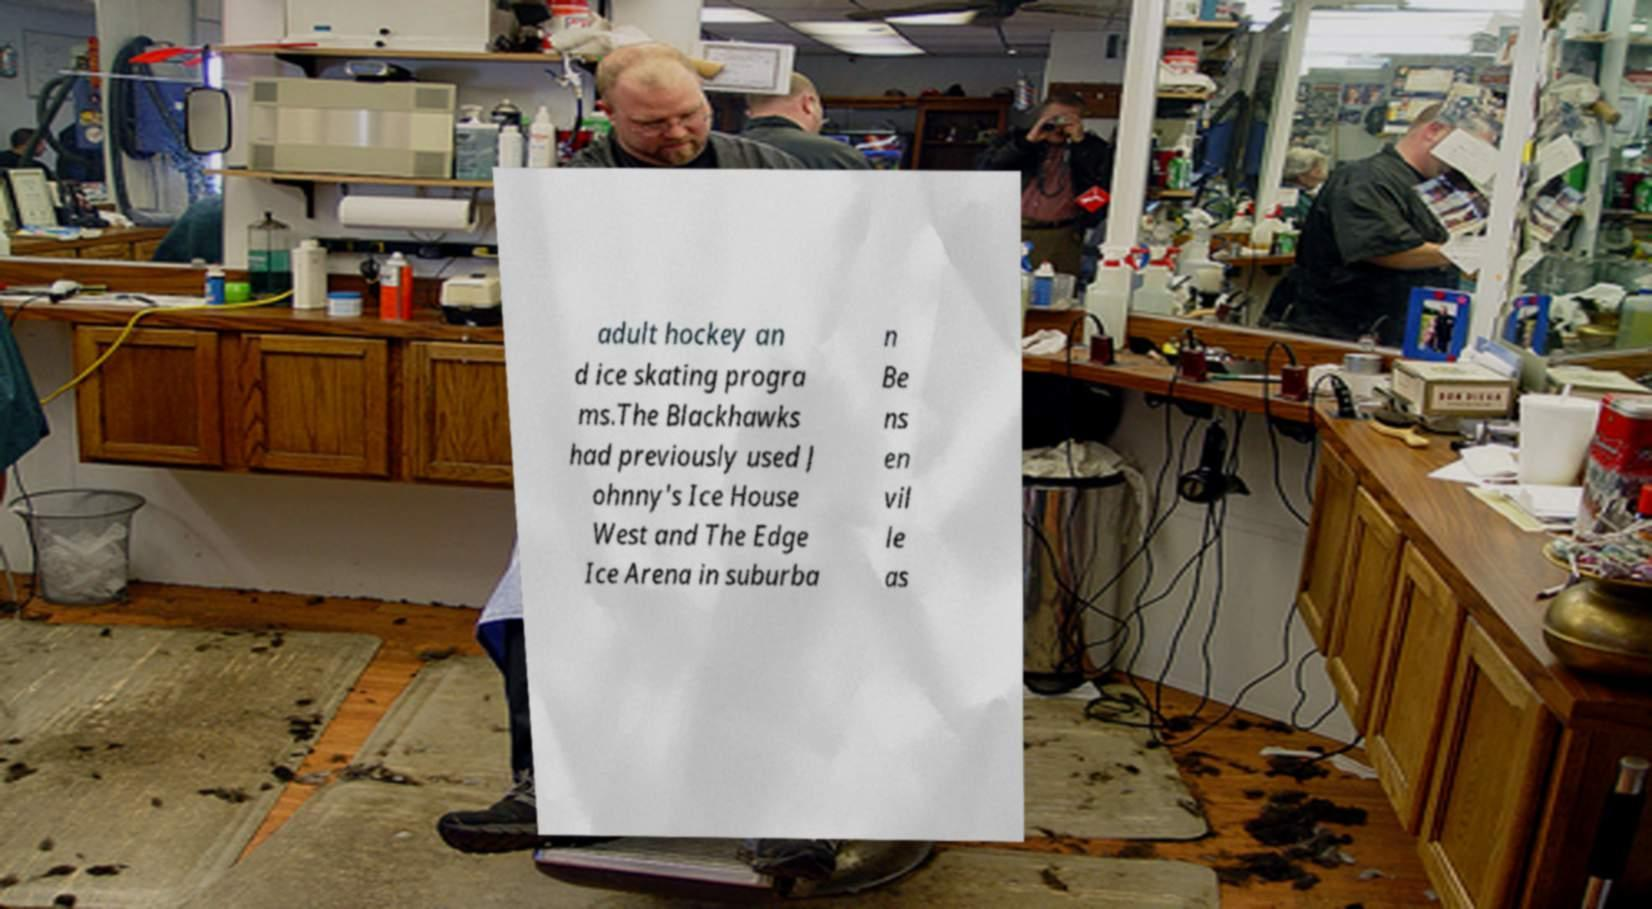Could you assist in decoding the text presented in this image and type it out clearly? adult hockey an d ice skating progra ms.The Blackhawks had previously used J ohnny's Ice House West and The Edge Ice Arena in suburba n Be ns en vil le as 